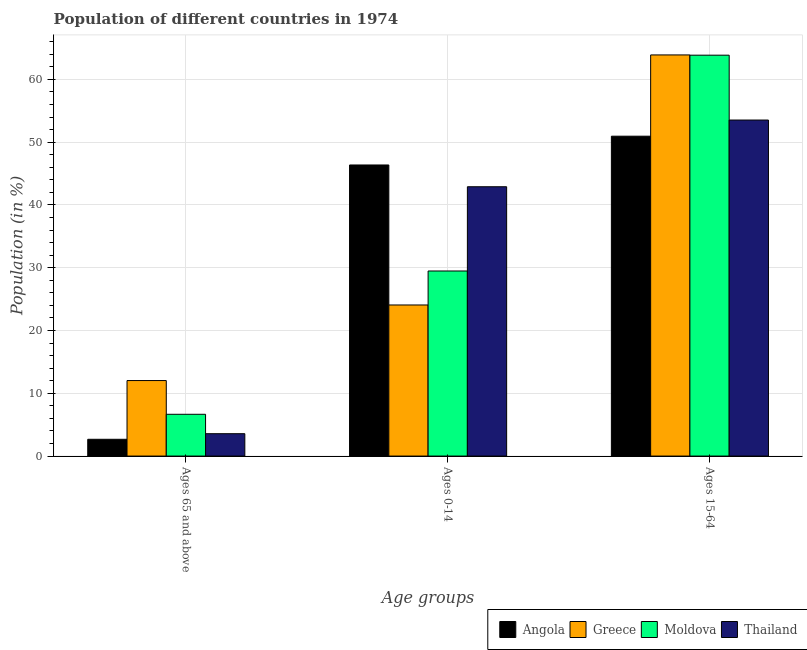Are the number of bars per tick equal to the number of legend labels?
Keep it short and to the point. Yes. What is the label of the 1st group of bars from the left?
Your response must be concise. Ages 65 and above. What is the percentage of population within the age-group of 65 and above in Greece?
Ensure brevity in your answer.  12.03. Across all countries, what is the maximum percentage of population within the age-group 0-14?
Offer a terse response. 46.37. Across all countries, what is the minimum percentage of population within the age-group 15-64?
Provide a short and direct response. 50.96. In which country was the percentage of population within the age-group 15-64 minimum?
Give a very brief answer. Angola. What is the total percentage of population within the age-group 0-14 in the graph?
Make the answer very short. 142.83. What is the difference between the percentage of population within the age-group 15-64 in Thailand and that in Greece?
Your response must be concise. -10.37. What is the difference between the percentage of population within the age-group 15-64 in Thailand and the percentage of population within the age-group 0-14 in Angola?
Offer a very short reply. 7.16. What is the average percentage of population within the age-group 0-14 per country?
Offer a terse response. 35.71. What is the difference between the percentage of population within the age-group of 65 and above and percentage of population within the age-group 15-64 in Moldova?
Offer a terse response. -57.21. In how many countries, is the percentage of population within the age-group 0-14 greater than 50 %?
Keep it short and to the point. 0. What is the ratio of the percentage of population within the age-group 15-64 in Thailand to that in Moldova?
Your answer should be compact. 0.84. Is the difference between the percentage of population within the age-group 15-64 in Angola and Thailand greater than the difference between the percentage of population within the age-group of 65 and above in Angola and Thailand?
Offer a terse response. No. What is the difference between the highest and the second highest percentage of population within the age-group of 65 and above?
Keep it short and to the point. 5.37. What is the difference between the highest and the lowest percentage of population within the age-group 15-64?
Provide a short and direct response. 12.95. In how many countries, is the percentage of population within the age-group 15-64 greater than the average percentage of population within the age-group 15-64 taken over all countries?
Ensure brevity in your answer.  2. Is the sum of the percentage of population within the age-group 0-14 in Moldova and Greece greater than the maximum percentage of population within the age-group of 65 and above across all countries?
Your answer should be compact. Yes. What does the 1st bar from the right in Ages 15-64 represents?
Your answer should be compact. Thailand. Are all the bars in the graph horizontal?
Your response must be concise. No. How many countries are there in the graph?
Provide a short and direct response. 4. Does the graph contain grids?
Give a very brief answer. Yes. What is the title of the graph?
Your answer should be compact. Population of different countries in 1974. Does "Tunisia" appear as one of the legend labels in the graph?
Your answer should be very brief. No. What is the label or title of the X-axis?
Provide a short and direct response. Age groups. What is the label or title of the Y-axis?
Provide a short and direct response. Population (in %). What is the Population (in %) in Angola in Ages 65 and above?
Your response must be concise. 2.67. What is the Population (in %) of Greece in Ages 65 and above?
Offer a very short reply. 12.03. What is the Population (in %) in Moldova in Ages 65 and above?
Keep it short and to the point. 6.66. What is the Population (in %) in Thailand in Ages 65 and above?
Provide a succinct answer. 3.56. What is the Population (in %) in Angola in Ages 0-14?
Your response must be concise. 46.37. What is the Population (in %) in Greece in Ages 0-14?
Your answer should be very brief. 24.07. What is the Population (in %) of Moldova in Ages 0-14?
Your response must be concise. 29.48. What is the Population (in %) of Thailand in Ages 0-14?
Your response must be concise. 42.9. What is the Population (in %) in Angola in Ages 15-64?
Keep it short and to the point. 50.96. What is the Population (in %) of Greece in Ages 15-64?
Provide a succinct answer. 63.9. What is the Population (in %) of Moldova in Ages 15-64?
Your answer should be compact. 63.86. What is the Population (in %) of Thailand in Ages 15-64?
Offer a terse response. 53.53. Across all Age groups, what is the maximum Population (in %) of Angola?
Offer a very short reply. 50.96. Across all Age groups, what is the maximum Population (in %) of Greece?
Provide a short and direct response. 63.9. Across all Age groups, what is the maximum Population (in %) of Moldova?
Offer a very short reply. 63.86. Across all Age groups, what is the maximum Population (in %) in Thailand?
Your answer should be very brief. 53.53. Across all Age groups, what is the minimum Population (in %) in Angola?
Ensure brevity in your answer.  2.67. Across all Age groups, what is the minimum Population (in %) in Greece?
Offer a very short reply. 12.03. Across all Age groups, what is the minimum Population (in %) of Moldova?
Your answer should be compact. 6.66. Across all Age groups, what is the minimum Population (in %) of Thailand?
Provide a succinct answer. 3.56. What is the total Population (in %) of Greece in the graph?
Keep it short and to the point. 100. What is the total Population (in %) of Moldova in the graph?
Keep it short and to the point. 100. What is the difference between the Population (in %) of Angola in Ages 65 and above and that in Ages 0-14?
Provide a short and direct response. -43.7. What is the difference between the Population (in %) of Greece in Ages 65 and above and that in Ages 0-14?
Give a very brief answer. -12.04. What is the difference between the Population (in %) in Moldova in Ages 65 and above and that in Ages 0-14?
Offer a very short reply. -22.83. What is the difference between the Population (in %) of Thailand in Ages 65 and above and that in Ages 0-14?
Ensure brevity in your answer.  -39.34. What is the difference between the Population (in %) in Angola in Ages 65 and above and that in Ages 15-64?
Ensure brevity in your answer.  -48.28. What is the difference between the Population (in %) in Greece in Ages 65 and above and that in Ages 15-64?
Make the answer very short. -51.87. What is the difference between the Population (in %) of Moldova in Ages 65 and above and that in Ages 15-64?
Give a very brief answer. -57.21. What is the difference between the Population (in %) in Thailand in Ages 65 and above and that in Ages 15-64?
Provide a short and direct response. -49.97. What is the difference between the Population (in %) of Angola in Ages 0-14 and that in Ages 15-64?
Your answer should be very brief. -4.58. What is the difference between the Population (in %) of Greece in Ages 0-14 and that in Ages 15-64?
Keep it short and to the point. -39.83. What is the difference between the Population (in %) of Moldova in Ages 0-14 and that in Ages 15-64?
Keep it short and to the point. -34.38. What is the difference between the Population (in %) of Thailand in Ages 0-14 and that in Ages 15-64?
Provide a succinct answer. -10.63. What is the difference between the Population (in %) in Angola in Ages 65 and above and the Population (in %) in Greece in Ages 0-14?
Provide a succinct answer. -21.4. What is the difference between the Population (in %) of Angola in Ages 65 and above and the Population (in %) of Moldova in Ages 0-14?
Your answer should be compact. -26.81. What is the difference between the Population (in %) of Angola in Ages 65 and above and the Population (in %) of Thailand in Ages 0-14?
Give a very brief answer. -40.23. What is the difference between the Population (in %) of Greece in Ages 65 and above and the Population (in %) of Moldova in Ages 0-14?
Offer a very short reply. -17.45. What is the difference between the Population (in %) of Greece in Ages 65 and above and the Population (in %) of Thailand in Ages 0-14?
Ensure brevity in your answer.  -30.87. What is the difference between the Population (in %) of Moldova in Ages 65 and above and the Population (in %) of Thailand in Ages 0-14?
Give a very brief answer. -36.25. What is the difference between the Population (in %) of Angola in Ages 65 and above and the Population (in %) of Greece in Ages 15-64?
Your response must be concise. -61.23. What is the difference between the Population (in %) in Angola in Ages 65 and above and the Population (in %) in Moldova in Ages 15-64?
Keep it short and to the point. -61.19. What is the difference between the Population (in %) of Angola in Ages 65 and above and the Population (in %) of Thailand in Ages 15-64?
Provide a succinct answer. -50.86. What is the difference between the Population (in %) in Greece in Ages 65 and above and the Population (in %) in Moldova in Ages 15-64?
Your response must be concise. -51.83. What is the difference between the Population (in %) in Greece in Ages 65 and above and the Population (in %) in Thailand in Ages 15-64?
Ensure brevity in your answer.  -41.5. What is the difference between the Population (in %) in Moldova in Ages 65 and above and the Population (in %) in Thailand in Ages 15-64?
Provide a short and direct response. -46.88. What is the difference between the Population (in %) of Angola in Ages 0-14 and the Population (in %) of Greece in Ages 15-64?
Give a very brief answer. -17.53. What is the difference between the Population (in %) of Angola in Ages 0-14 and the Population (in %) of Moldova in Ages 15-64?
Ensure brevity in your answer.  -17.49. What is the difference between the Population (in %) in Angola in Ages 0-14 and the Population (in %) in Thailand in Ages 15-64?
Your answer should be very brief. -7.16. What is the difference between the Population (in %) of Greece in Ages 0-14 and the Population (in %) of Moldova in Ages 15-64?
Your answer should be compact. -39.79. What is the difference between the Population (in %) of Greece in Ages 0-14 and the Population (in %) of Thailand in Ages 15-64?
Keep it short and to the point. -29.46. What is the difference between the Population (in %) in Moldova in Ages 0-14 and the Population (in %) in Thailand in Ages 15-64?
Provide a succinct answer. -24.05. What is the average Population (in %) in Angola per Age groups?
Offer a terse response. 33.33. What is the average Population (in %) of Greece per Age groups?
Your response must be concise. 33.33. What is the average Population (in %) of Moldova per Age groups?
Provide a short and direct response. 33.33. What is the average Population (in %) of Thailand per Age groups?
Offer a terse response. 33.33. What is the difference between the Population (in %) of Angola and Population (in %) of Greece in Ages 65 and above?
Provide a short and direct response. -9.36. What is the difference between the Population (in %) in Angola and Population (in %) in Moldova in Ages 65 and above?
Your answer should be compact. -3.98. What is the difference between the Population (in %) in Angola and Population (in %) in Thailand in Ages 65 and above?
Your response must be concise. -0.89. What is the difference between the Population (in %) in Greece and Population (in %) in Moldova in Ages 65 and above?
Offer a terse response. 5.37. What is the difference between the Population (in %) of Greece and Population (in %) of Thailand in Ages 65 and above?
Offer a very short reply. 8.46. What is the difference between the Population (in %) in Moldova and Population (in %) in Thailand in Ages 65 and above?
Provide a succinct answer. 3.09. What is the difference between the Population (in %) in Angola and Population (in %) in Greece in Ages 0-14?
Give a very brief answer. 22.3. What is the difference between the Population (in %) in Angola and Population (in %) in Moldova in Ages 0-14?
Make the answer very short. 16.89. What is the difference between the Population (in %) of Angola and Population (in %) of Thailand in Ages 0-14?
Your answer should be very brief. 3.47. What is the difference between the Population (in %) in Greece and Population (in %) in Moldova in Ages 0-14?
Offer a very short reply. -5.41. What is the difference between the Population (in %) in Greece and Population (in %) in Thailand in Ages 0-14?
Provide a succinct answer. -18.84. What is the difference between the Population (in %) of Moldova and Population (in %) of Thailand in Ages 0-14?
Keep it short and to the point. -13.42. What is the difference between the Population (in %) of Angola and Population (in %) of Greece in Ages 15-64?
Keep it short and to the point. -12.95. What is the difference between the Population (in %) of Angola and Population (in %) of Moldova in Ages 15-64?
Your answer should be very brief. -12.91. What is the difference between the Population (in %) in Angola and Population (in %) in Thailand in Ages 15-64?
Offer a very short reply. -2.58. What is the difference between the Population (in %) in Greece and Population (in %) in Moldova in Ages 15-64?
Your answer should be compact. 0.04. What is the difference between the Population (in %) of Greece and Population (in %) of Thailand in Ages 15-64?
Your response must be concise. 10.37. What is the difference between the Population (in %) in Moldova and Population (in %) in Thailand in Ages 15-64?
Offer a very short reply. 10.33. What is the ratio of the Population (in %) in Angola in Ages 65 and above to that in Ages 0-14?
Give a very brief answer. 0.06. What is the ratio of the Population (in %) of Greece in Ages 65 and above to that in Ages 0-14?
Give a very brief answer. 0.5. What is the ratio of the Population (in %) in Moldova in Ages 65 and above to that in Ages 0-14?
Your answer should be very brief. 0.23. What is the ratio of the Population (in %) in Thailand in Ages 65 and above to that in Ages 0-14?
Ensure brevity in your answer.  0.08. What is the ratio of the Population (in %) in Angola in Ages 65 and above to that in Ages 15-64?
Your response must be concise. 0.05. What is the ratio of the Population (in %) of Greece in Ages 65 and above to that in Ages 15-64?
Provide a succinct answer. 0.19. What is the ratio of the Population (in %) in Moldova in Ages 65 and above to that in Ages 15-64?
Give a very brief answer. 0.1. What is the ratio of the Population (in %) in Thailand in Ages 65 and above to that in Ages 15-64?
Ensure brevity in your answer.  0.07. What is the ratio of the Population (in %) in Angola in Ages 0-14 to that in Ages 15-64?
Offer a very short reply. 0.91. What is the ratio of the Population (in %) in Greece in Ages 0-14 to that in Ages 15-64?
Give a very brief answer. 0.38. What is the ratio of the Population (in %) in Moldova in Ages 0-14 to that in Ages 15-64?
Give a very brief answer. 0.46. What is the ratio of the Population (in %) in Thailand in Ages 0-14 to that in Ages 15-64?
Your response must be concise. 0.8. What is the difference between the highest and the second highest Population (in %) in Angola?
Keep it short and to the point. 4.58. What is the difference between the highest and the second highest Population (in %) in Greece?
Make the answer very short. 39.83. What is the difference between the highest and the second highest Population (in %) in Moldova?
Keep it short and to the point. 34.38. What is the difference between the highest and the second highest Population (in %) in Thailand?
Give a very brief answer. 10.63. What is the difference between the highest and the lowest Population (in %) of Angola?
Keep it short and to the point. 48.28. What is the difference between the highest and the lowest Population (in %) of Greece?
Ensure brevity in your answer.  51.87. What is the difference between the highest and the lowest Population (in %) of Moldova?
Your response must be concise. 57.21. What is the difference between the highest and the lowest Population (in %) of Thailand?
Keep it short and to the point. 49.97. 